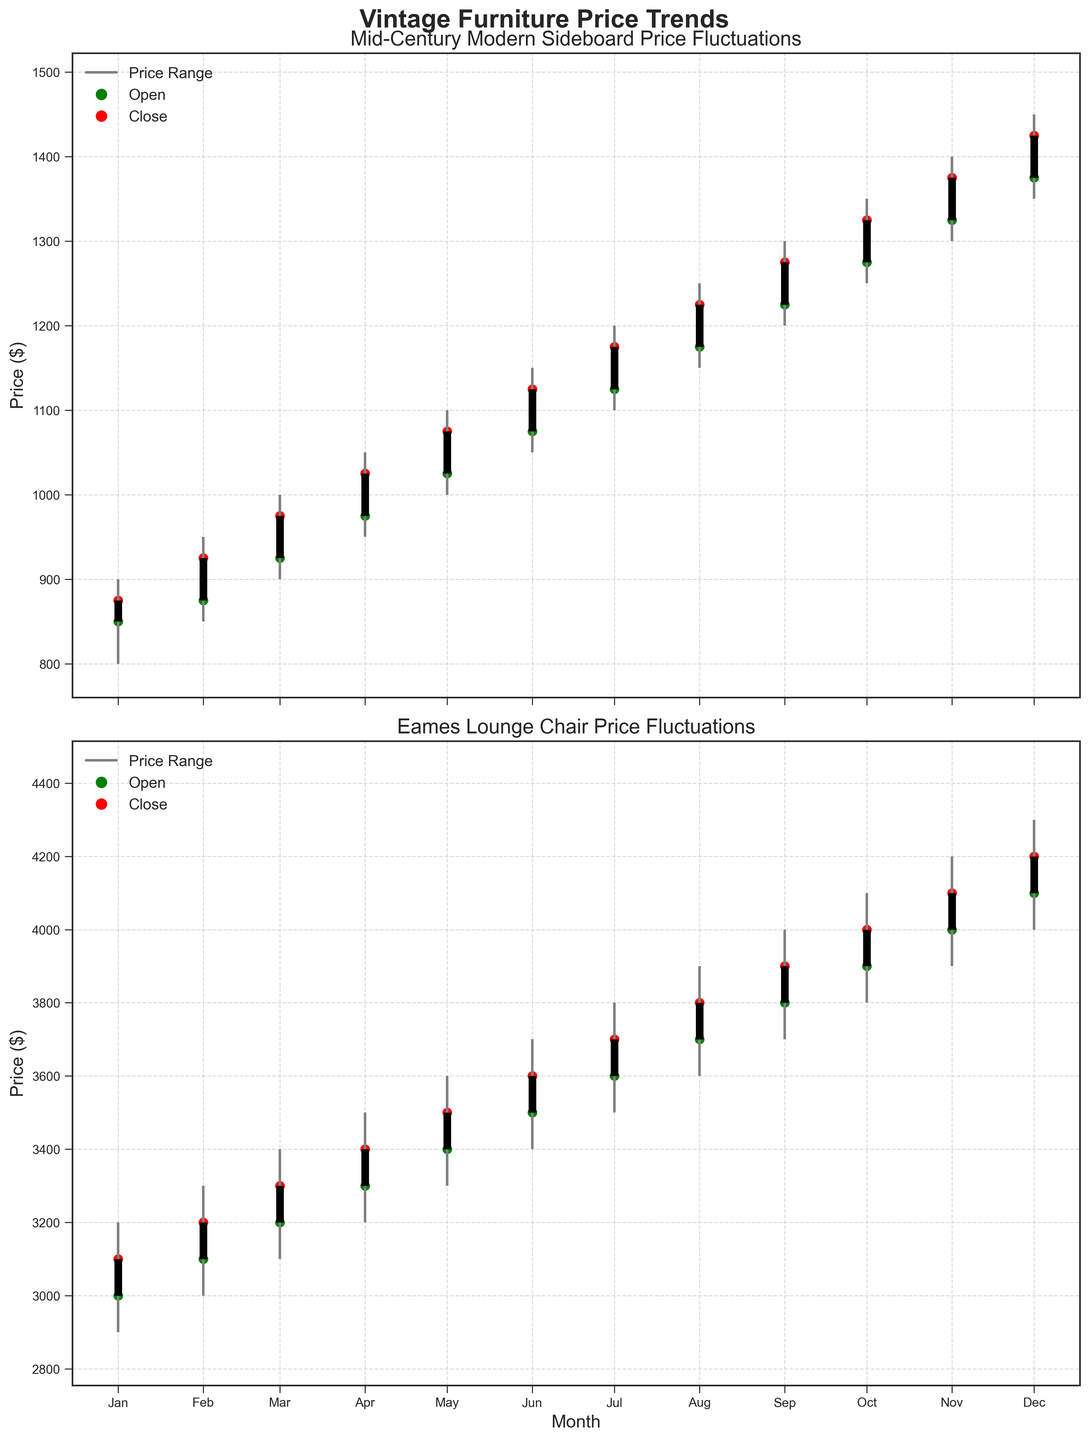What's the title of the chart? The title of the chart is usually displayed at the top, and it clearly indicates the subject of the data being presented. In this case, the title is "Vintage Furniture Price Trends".
Answer: Vintage Furniture Price Trends What is the price range for the 'Mid-Century Modern Sideboard' in January? For the month of January, the price range can be identified by looking at the vertical lines representing the low and high prices. The lowest price is at $800, and the highest is at $900. This range is indicated by the gray vertical line.
Answer: $800 to $900 Which month shows the highest closing price for the 'Eames Lounge Chair'? To find the month with the highest closing price for the 'Eames Lounge Chair,' look for the red markers and identify the month associated with the highest one. The highest closing price is $4200, which occurs in December.
Answer: December What's the average closing price for the 'Mid-Century Modern Sideboard' over the year? To get the average closing price, sum all the closing prices for each month and then divide by the total number of months. Specifically, sum ($875 + $925 + $975 + $1025 + $1075 + $1125 + $1175 + $1225 + $1275 + $1325 + $1375 + $1425) = $14400. Divide by 12 (total number of months) to get the average: $14400 / 12 = $1200.
Answer: $1200 Which item shows a more substantial price increase between January and December? To determine which item has a more significant price increase, compare the January and December closing prices for both items. For the 'Mid-Century Modern Sideboard,' the difference is $1425 - $875 = $550. For the 'Eames Lounge Chair,' the difference is $4200 - $3100 = $1100. The 'Eames Lounge Chair' shows a more substantial increase.
Answer: Eames Lounge Chair What is the pattern of the closing prices for the 'Mid-Century Modern Sideboard' through the year? Observing the red markers month-to-month for this item, it's clear that the closing prices follow an upward trend with consistent monthly increases, starting from $875 in January and reaching $1425 in December.
Answer: Upward trend How do the price fluctuations of both items compare in August? For August, compare the OHLC data for both items. 'Mid-Century Modern Sideboard' has a price range of $1150 to $1250, with an opening price of $1175 and a closing of $1225. The 'Eames Lounge Chair' has a price range of $3600 to $3900, with an opening price of $3700 and a closing of $3800. The 'Eames Lounge Chair' has a broader range of price fluctuations.
Answer: Eames Lounge Chair has broader fluctuations Which item shows the greatest volatility in any single month, and which month is it? Volatility can be deduced by the length of the price range lines. The month with the largest range between the low and high prices is most volatile. For the 'Eames Lounge Chair,' the greatest range is in October (from $3800 to $4100). For 'Mid-Century Modern Sideboard,' it's October too (from $1250 to $1350). However, the 'Eames Lounge Chair' shows a greater range and hence higher volatility.
Answer: Eames Lounge Chair in October 